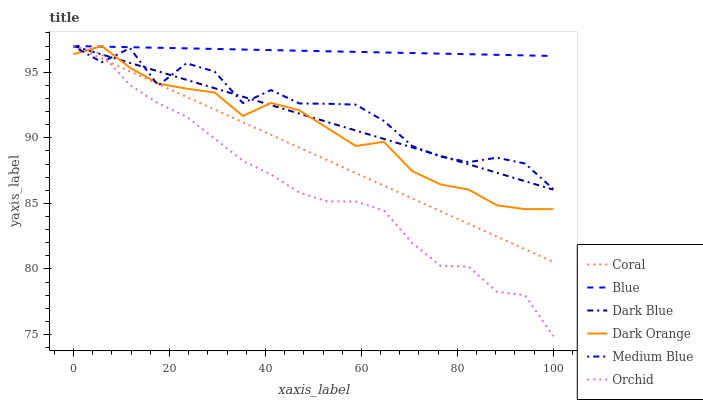Does Orchid have the minimum area under the curve?
Answer yes or no. Yes. Does Blue have the maximum area under the curve?
Answer yes or no. Yes. Does Dark Orange have the minimum area under the curve?
Answer yes or no. No. Does Dark Orange have the maximum area under the curve?
Answer yes or no. No. Is Coral the smoothest?
Answer yes or no. Yes. Is Medium Blue the roughest?
Answer yes or no. Yes. Is Dark Orange the smoothest?
Answer yes or no. No. Is Dark Orange the roughest?
Answer yes or no. No. Does Dark Orange have the lowest value?
Answer yes or no. No. Does Orchid have the highest value?
Answer yes or no. Yes. Does Medium Blue have the highest value?
Answer yes or no. No. Is Medium Blue less than Blue?
Answer yes or no. Yes. Is Blue greater than Medium Blue?
Answer yes or no. Yes. Does Medium Blue intersect Blue?
Answer yes or no. No. 